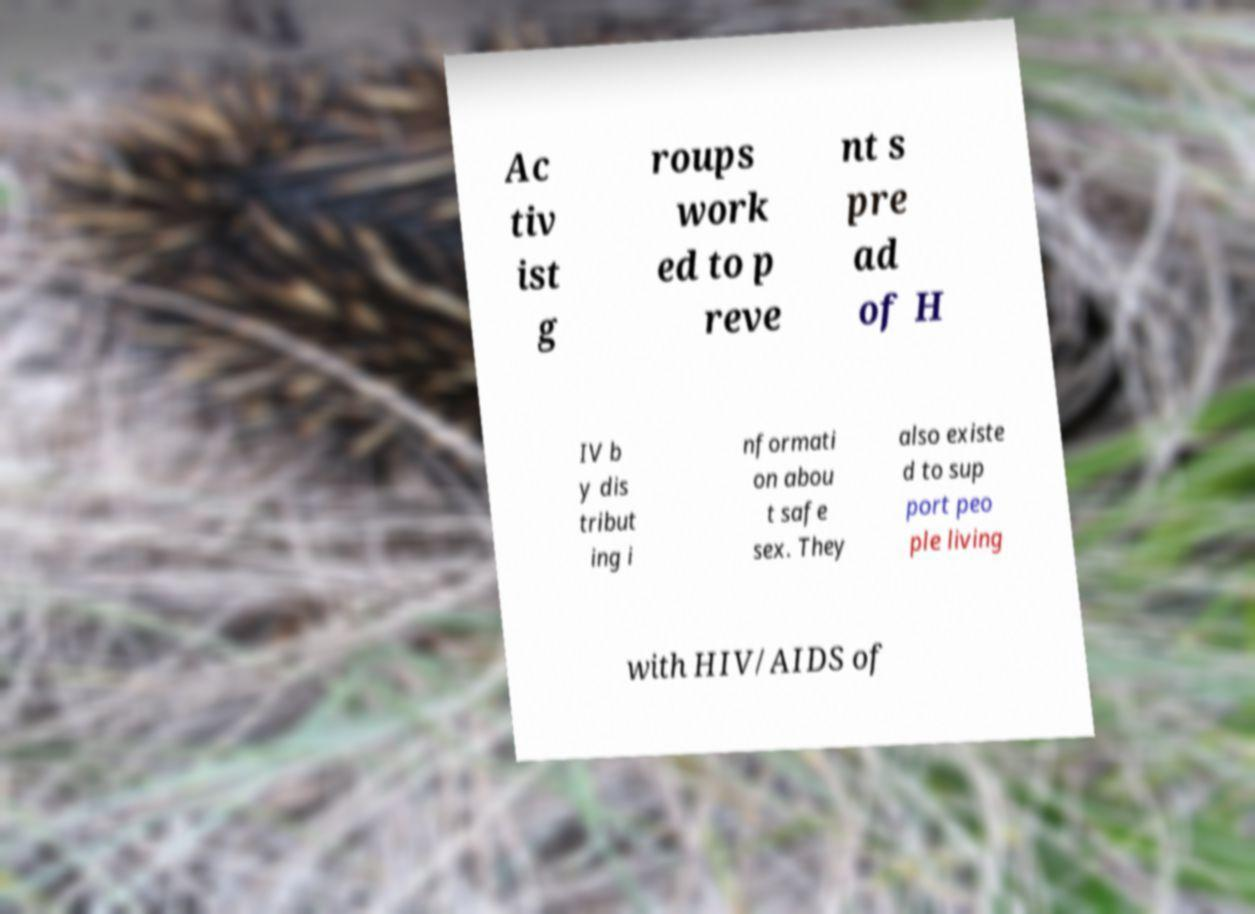Please identify and transcribe the text found in this image. Ac tiv ist g roups work ed to p reve nt s pre ad of H IV b y dis tribut ing i nformati on abou t safe sex. They also existe d to sup port peo ple living with HIV/AIDS of 